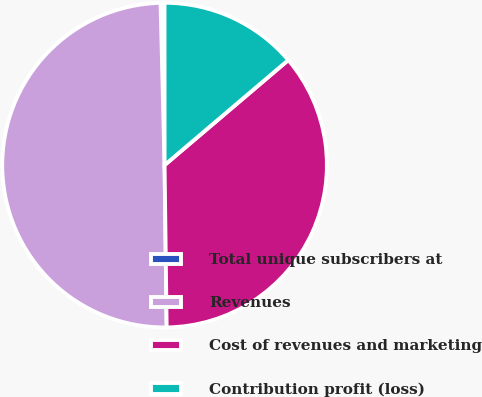Convert chart to OTSL. <chart><loc_0><loc_0><loc_500><loc_500><pie_chart><fcel>Total unique subscribers at<fcel>Revenues<fcel>Cost of revenues and marketing<fcel>Contribution profit (loss)<nl><fcel>0.39%<fcel>49.81%<fcel>36.0%<fcel>13.8%<nl></chart> 